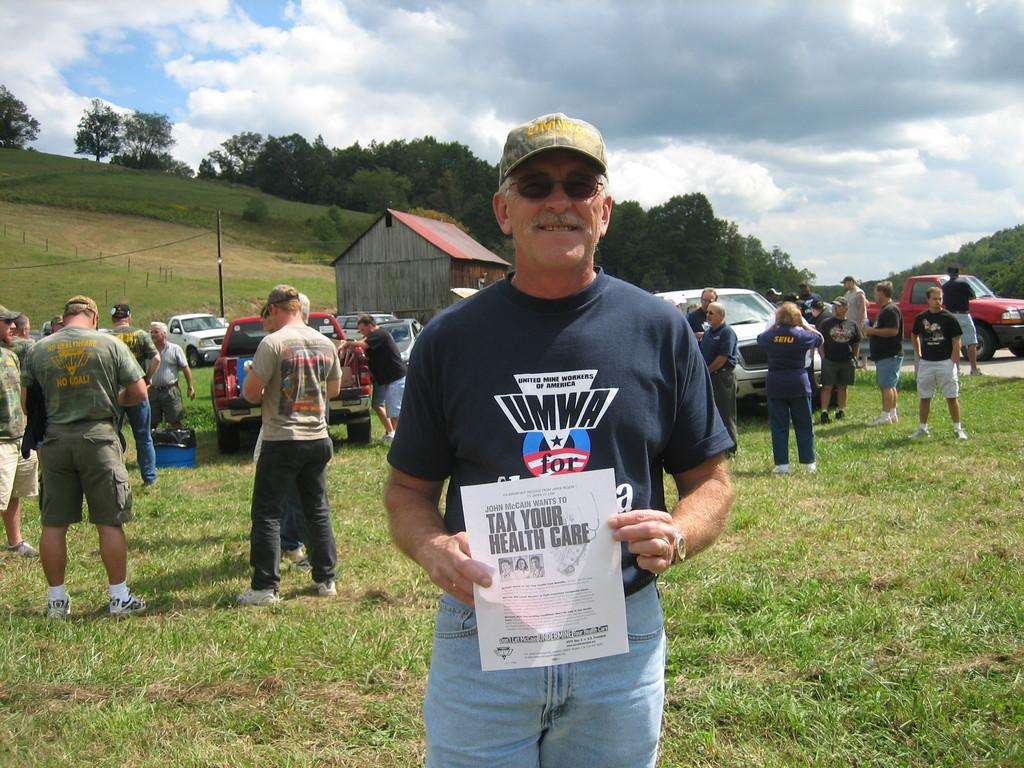How many people are present in the image? There is a group of people in the image, but the exact number cannot be determined from the provided facts. What are the vehicles on the grass in the image? The vehicles on the grass in the image are not specified in the provided facts. What is the person holding in the image? One person is holding a paper in the image. What is located in the background of the image? In the background of the image, there is a shed, many trees, clouds, and the sky. How many beds are visible in the image? There are no beds present in the image. What type of act is being performed by the group of people in the image? The provided facts do not mention any specific act being performed by the group of people in the image. 